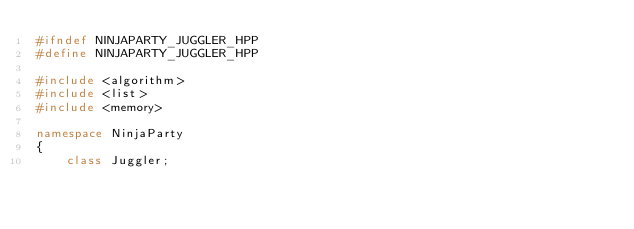Convert code to text. <code><loc_0><loc_0><loc_500><loc_500><_C++_>#ifndef NINJAPARTY_JUGGLER_HPP
#define NINJAPARTY_JUGGLER_HPP

#include <algorithm>
#include <list>
#include <memory>

namespace NinjaParty
{
	class Juggler;
	</code> 